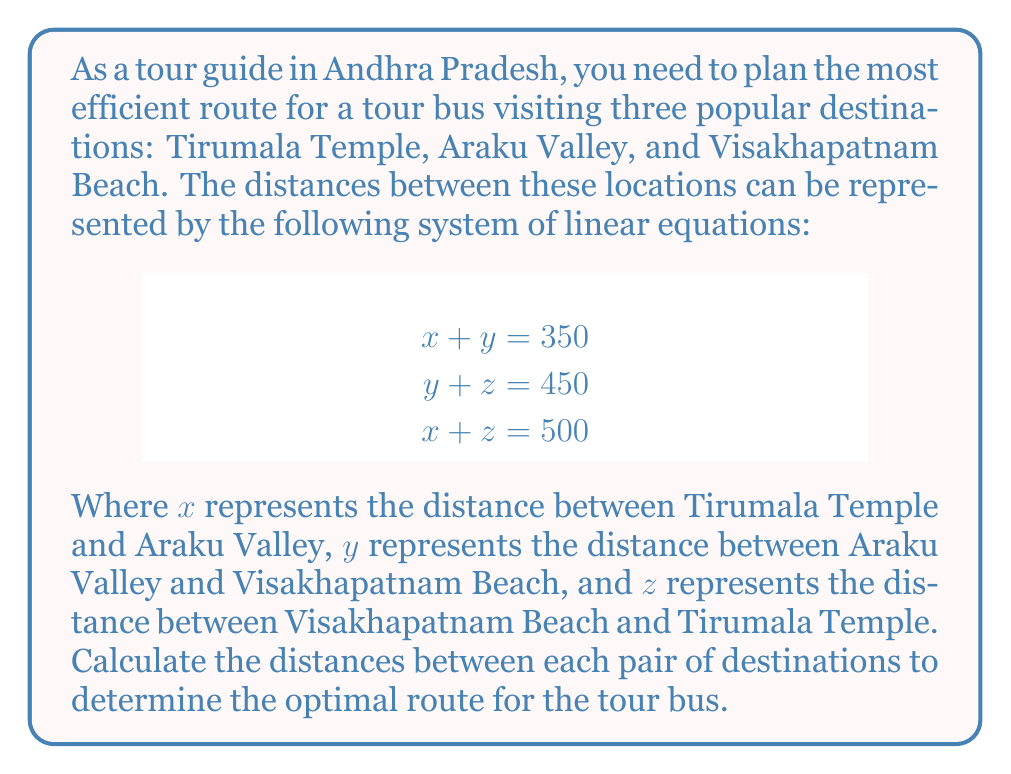Solve this math problem. To solve this system of linear equations, we can use the substitution method:

1. From the first equation, we can express $y$ in terms of $x$:
   $y = 350 - x$

2. Substitute this expression for $y$ into the second equation:
   $(350 - x) + z = 450$
   $350 - x + z = 450$
   $z = 100 + x$

3. Now substitute the expressions for $y$ and $z$ into the third equation:
   $x + (100 + x) = 500$
   $2x + 100 = 500$
   $2x = 400$
   $x = 200$

4. Now that we know $x$, we can calculate $y$ and $z$:
   $y = 350 - x = 350 - 200 = 150$
   $z = 100 + x = 100 + 200 = 300$

5. Verify the solution by substituting the values back into the original equations:
   $200 + 150 = 350$ (correct)
   $150 + 300 = 450$ (correct)
   $200 + 300 = 500$ (correct)

Therefore, the distances between each pair of destinations are:
- Tirumala Temple to Araku Valley: 200 km
- Araku Valley to Visakhapatnam Beach: 150 km
- Visakhapatnam Beach to Tirumala Temple: 300 km

The optimal route for the tour bus would be to start at Tirumala Temple, travel 200 km to Araku Valley, then 150 km to Visakhapatnam Beach, and finally 300 km back to Tirumala Temple, completing a round trip of 650 km.
Answer: The distances between each pair of destinations are:
$x = 200$ km (Tirumala Temple to Araku Valley)
$y = 150$ km (Araku Valley to Visakhapatnam Beach)
$z = 300$ km (Visakhapatnam Beach to Tirumala Temple)

The optimal route: Tirumala Temple → Araku Valley → Visakhapatnam Beach → Tirumala Temple (650 km total) 